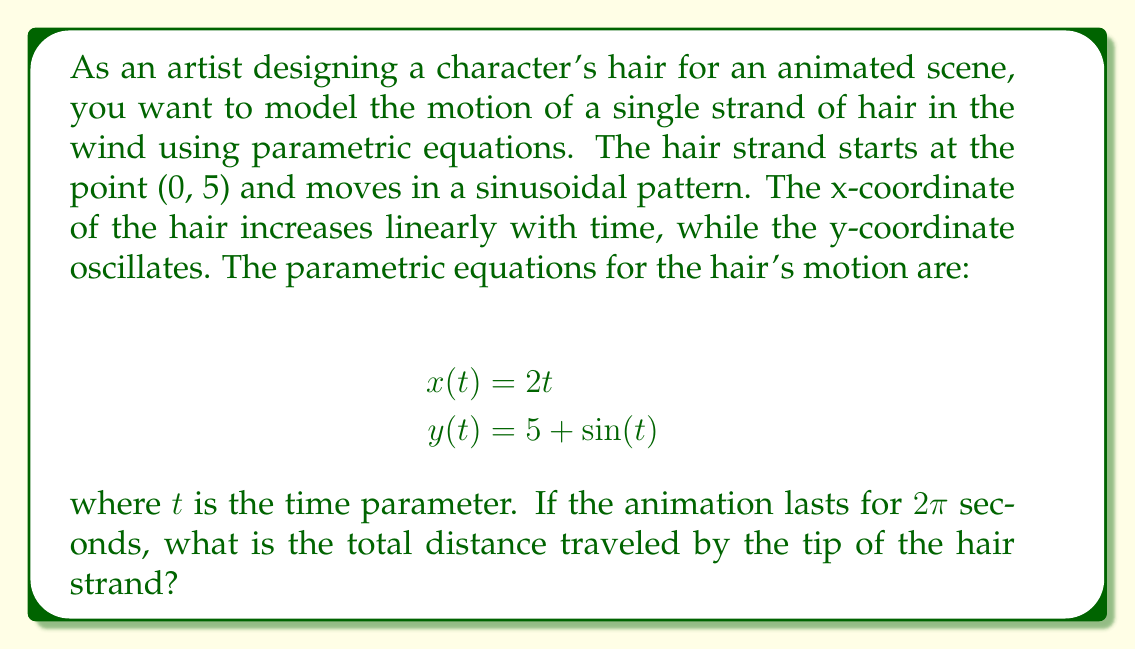Solve this math problem. To find the total distance traveled by the tip of the hair strand, we need to calculate the arc length of the parametric curve over the given time interval. We'll follow these steps:

1) The arc length formula for a parametric curve is:

   $$L = \int_{a}^{b} \sqrt{\left(\frac{dx}{dt}\right)^2 + \left(\frac{dy}{dt}\right)^2} dt$$

2) First, we need to find $\frac{dx}{dt}$ and $\frac{dy}{dt}$:
   
   $$\frac{dx}{dt} = 2$$
   $$\frac{dy}{dt} = \cos(t)$$

3) Now, let's substitute these into the arc length formula:

   $$L = \int_{0}^{2\pi} \sqrt{2^2 + \cos^2(t)} dt$$

4) Simplify under the square root:

   $$L = \int_{0}^{2\pi} \sqrt{4 + \cos^2(t)} dt$$

5) This integral doesn't have an elementary antiderivative, so we need to use numerical integration methods to approximate it. Using a computer algebra system or numerical integration tool, we can evaluate this integral:

   $$L \approx 12.8767$$

6) Rounding to two decimal places, we get the final answer.
Answer: The total distance traveled by the tip of the hair strand is approximately 12.88 units. 